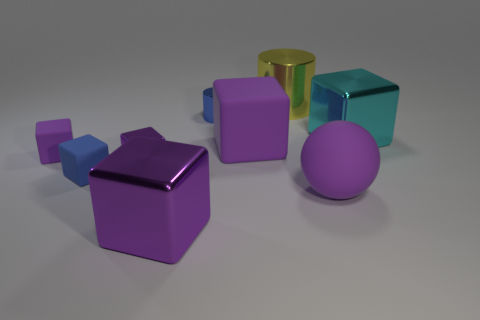How many purple blocks must be subtracted to get 2 purple blocks? 2 Subtract all green cylinders. How many purple blocks are left? 4 Subtract 3 blocks. How many blocks are left? 3 Subtract all blue blocks. How many blocks are left? 5 Subtract all big purple shiny cubes. How many cubes are left? 5 Subtract all yellow cubes. Subtract all yellow balls. How many cubes are left? 6 Add 1 big yellow metallic things. How many objects exist? 10 Subtract all spheres. How many objects are left? 8 Subtract 0 cyan cylinders. How many objects are left? 9 Subtract all cyan metallic things. Subtract all blue rubber blocks. How many objects are left? 7 